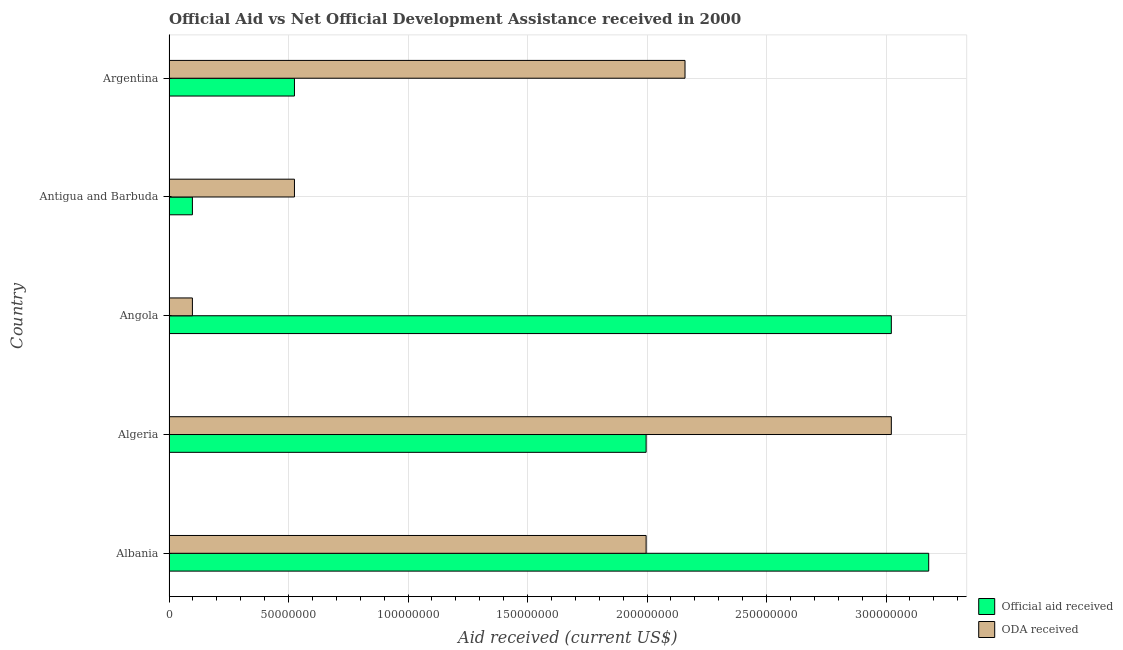Are the number of bars per tick equal to the number of legend labels?
Provide a succinct answer. Yes. Are the number of bars on each tick of the Y-axis equal?
Provide a succinct answer. Yes. How many bars are there on the 3rd tick from the top?
Provide a succinct answer. 2. What is the label of the 3rd group of bars from the top?
Your response must be concise. Angola. In how many cases, is the number of bars for a given country not equal to the number of legend labels?
Offer a very short reply. 0. What is the official aid received in Argentina?
Offer a very short reply. 5.25e+07. Across all countries, what is the maximum oda received?
Ensure brevity in your answer.  3.02e+08. Across all countries, what is the minimum official aid received?
Provide a short and direct response. 9.79e+06. In which country was the official aid received maximum?
Provide a short and direct response. Albania. In which country was the official aid received minimum?
Your answer should be compact. Antigua and Barbuda. What is the total oda received in the graph?
Provide a succinct answer. 7.80e+08. What is the difference between the official aid received in Albania and that in Algeria?
Your answer should be very brief. 1.18e+08. What is the difference between the official aid received in Angola and the oda received in Algeria?
Give a very brief answer. 0. What is the average oda received per country?
Keep it short and to the point. 1.56e+08. What is the difference between the official aid received and oda received in Angola?
Ensure brevity in your answer.  2.92e+08. In how many countries, is the official aid received greater than 40000000 US$?
Your response must be concise. 4. What is the ratio of the official aid received in Albania to that in Argentina?
Provide a short and direct response. 6.05. Is the official aid received in Angola less than that in Antigua and Barbuda?
Give a very brief answer. No. Is the difference between the oda received in Albania and Algeria greater than the difference between the official aid received in Albania and Algeria?
Provide a succinct answer. No. What is the difference between the highest and the second highest official aid received?
Provide a succinct answer. 1.56e+07. What is the difference between the highest and the lowest oda received?
Your answer should be very brief. 2.92e+08. In how many countries, is the oda received greater than the average oda received taken over all countries?
Keep it short and to the point. 3. What does the 2nd bar from the top in Angola represents?
Keep it short and to the point. Official aid received. What does the 2nd bar from the bottom in Antigua and Barbuda represents?
Offer a very short reply. ODA received. How many countries are there in the graph?
Provide a succinct answer. 5. What is the difference between two consecutive major ticks on the X-axis?
Your answer should be compact. 5.00e+07. Where does the legend appear in the graph?
Give a very brief answer. Bottom right. How many legend labels are there?
Give a very brief answer. 2. How are the legend labels stacked?
Provide a succinct answer. Vertical. What is the title of the graph?
Ensure brevity in your answer.  Official Aid vs Net Official Development Assistance received in 2000 . What is the label or title of the X-axis?
Ensure brevity in your answer.  Aid received (current US$). What is the Aid received (current US$) in Official aid received in Albania?
Your answer should be very brief. 3.18e+08. What is the Aid received (current US$) in ODA received in Albania?
Make the answer very short. 2.00e+08. What is the Aid received (current US$) of Official aid received in Algeria?
Keep it short and to the point. 2.00e+08. What is the Aid received (current US$) in ODA received in Algeria?
Ensure brevity in your answer.  3.02e+08. What is the Aid received (current US$) in Official aid received in Angola?
Provide a short and direct response. 3.02e+08. What is the Aid received (current US$) of ODA received in Angola?
Your answer should be compact. 9.79e+06. What is the Aid received (current US$) in Official aid received in Antigua and Barbuda?
Provide a short and direct response. 9.79e+06. What is the Aid received (current US$) of ODA received in Antigua and Barbuda?
Offer a terse response. 5.25e+07. What is the Aid received (current US$) of Official aid received in Argentina?
Give a very brief answer. 5.25e+07. What is the Aid received (current US$) in ODA received in Argentina?
Provide a succinct answer. 2.16e+08. Across all countries, what is the maximum Aid received (current US$) of Official aid received?
Make the answer very short. 3.18e+08. Across all countries, what is the maximum Aid received (current US$) of ODA received?
Provide a succinct answer. 3.02e+08. Across all countries, what is the minimum Aid received (current US$) in Official aid received?
Your answer should be compact. 9.79e+06. Across all countries, what is the minimum Aid received (current US$) of ODA received?
Offer a very short reply. 9.79e+06. What is the total Aid received (current US$) of Official aid received in the graph?
Provide a succinct answer. 8.82e+08. What is the total Aid received (current US$) of ODA received in the graph?
Make the answer very short. 7.80e+08. What is the difference between the Aid received (current US$) of Official aid received in Albania and that in Algeria?
Your answer should be very brief. 1.18e+08. What is the difference between the Aid received (current US$) in ODA received in Albania and that in Algeria?
Offer a very short reply. -1.03e+08. What is the difference between the Aid received (current US$) of Official aid received in Albania and that in Angola?
Offer a terse response. 1.56e+07. What is the difference between the Aid received (current US$) in ODA received in Albania and that in Angola?
Provide a succinct answer. 1.90e+08. What is the difference between the Aid received (current US$) of Official aid received in Albania and that in Antigua and Barbuda?
Offer a very short reply. 3.08e+08. What is the difference between the Aid received (current US$) of ODA received in Albania and that in Antigua and Barbuda?
Your response must be concise. 1.47e+08. What is the difference between the Aid received (current US$) in Official aid received in Albania and that in Argentina?
Your answer should be very brief. 2.65e+08. What is the difference between the Aid received (current US$) of ODA received in Albania and that in Argentina?
Ensure brevity in your answer.  -1.63e+07. What is the difference between the Aid received (current US$) of Official aid received in Algeria and that in Angola?
Offer a very short reply. -1.03e+08. What is the difference between the Aid received (current US$) of ODA received in Algeria and that in Angola?
Give a very brief answer. 2.92e+08. What is the difference between the Aid received (current US$) in Official aid received in Algeria and that in Antigua and Barbuda?
Provide a short and direct response. 1.90e+08. What is the difference between the Aid received (current US$) in ODA received in Algeria and that in Antigua and Barbuda?
Keep it short and to the point. 2.50e+08. What is the difference between the Aid received (current US$) in Official aid received in Algeria and that in Argentina?
Give a very brief answer. 1.47e+08. What is the difference between the Aid received (current US$) in ODA received in Algeria and that in Argentina?
Your answer should be compact. 8.63e+07. What is the difference between the Aid received (current US$) of Official aid received in Angola and that in Antigua and Barbuda?
Your response must be concise. 2.92e+08. What is the difference between the Aid received (current US$) in ODA received in Angola and that in Antigua and Barbuda?
Ensure brevity in your answer.  -4.27e+07. What is the difference between the Aid received (current US$) in Official aid received in Angola and that in Argentina?
Keep it short and to the point. 2.50e+08. What is the difference between the Aid received (current US$) in ODA received in Angola and that in Argentina?
Your answer should be very brief. -2.06e+08. What is the difference between the Aid received (current US$) of Official aid received in Antigua and Barbuda and that in Argentina?
Provide a succinct answer. -4.27e+07. What is the difference between the Aid received (current US$) in ODA received in Antigua and Barbuda and that in Argentina?
Provide a short and direct response. -1.63e+08. What is the difference between the Aid received (current US$) in Official aid received in Albania and the Aid received (current US$) in ODA received in Algeria?
Your answer should be very brief. 1.56e+07. What is the difference between the Aid received (current US$) of Official aid received in Albania and the Aid received (current US$) of ODA received in Angola?
Your response must be concise. 3.08e+08. What is the difference between the Aid received (current US$) of Official aid received in Albania and the Aid received (current US$) of ODA received in Antigua and Barbuda?
Make the answer very short. 2.65e+08. What is the difference between the Aid received (current US$) of Official aid received in Albania and the Aid received (current US$) of ODA received in Argentina?
Your response must be concise. 1.02e+08. What is the difference between the Aid received (current US$) of Official aid received in Algeria and the Aid received (current US$) of ODA received in Angola?
Your answer should be very brief. 1.90e+08. What is the difference between the Aid received (current US$) in Official aid received in Algeria and the Aid received (current US$) in ODA received in Antigua and Barbuda?
Provide a succinct answer. 1.47e+08. What is the difference between the Aid received (current US$) in Official aid received in Algeria and the Aid received (current US$) in ODA received in Argentina?
Your answer should be very brief. -1.63e+07. What is the difference between the Aid received (current US$) of Official aid received in Angola and the Aid received (current US$) of ODA received in Antigua and Barbuda?
Provide a succinct answer. 2.50e+08. What is the difference between the Aid received (current US$) of Official aid received in Angola and the Aid received (current US$) of ODA received in Argentina?
Offer a very short reply. 8.63e+07. What is the difference between the Aid received (current US$) of Official aid received in Antigua and Barbuda and the Aid received (current US$) of ODA received in Argentina?
Give a very brief answer. -2.06e+08. What is the average Aid received (current US$) in Official aid received per country?
Your response must be concise. 1.76e+08. What is the average Aid received (current US$) of ODA received per country?
Ensure brevity in your answer.  1.56e+08. What is the difference between the Aid received (current US$) of Official aid received and Aid received (current US$) of ODA received in Albania?
Provide a succinct answer. 1.18e+08. What is the difference between the Aid received (current US$) of Official aid received and Aid received (current US$) of ODA received in Algeria?
Your response must be concise. -1.03e+08. What is the difference between the Aid received (current US$) in Official aid received and Aid received (current US$) in ODA received in Angola?
Your response must be concise. 2.92e+08. What is the difference between the Aid received (current US$) in Official aid received and Aid received (current US$) in ODA received in Antigua and Barbuda?
Offer a very short reply. -4.27e+07. What is the difference between the Aid received (current US$) of Official aid received and Aid received (current US$) of ODA received in Argentina?
Provide a short and direct response. -1.63e+08. What is the ratio of the Aid received (current US$) in Official aid received in Albania to that in Algeria?
Provide a succinct answer. 1.59. What is the ratio of the Aid received (current US$) in ODA received in Albania to that in Algeria?
Make the answer very short. 0.66. What is the ratio of the Aid received (current US$) of Official aid received in Albania to that in Angola?
Your answer should be very brief. 1.05. What is the ratio of the Aid received (current US$) of ODA received in Albania to that in Angola?
Ensure brevity in your answer.  20.39. What is the ratio of the Aid received (current US$) of Official aid received in Albania to that in Antigua and Barbuda?
Your response must be concise. 32.47. What is the ratio of the Aid received (current US$) of ODA received in Albania to that in Antigua and Barbuda?
Offer a terse response. 3.8. What is the ratio of the Aid received (current US$) in Official aid received in Albania to that in Argentina?
Make the answer very short. 6.06. What is the ratio of the Aid received (current US$) in ODA received in Albania to that in Argentina?
Your answer should be very brief. 0.92. What is the ratio of the Aid received (current US$) of Official aid received in Algeria to that in Angola?
Keep it short and to the point. 0.66. What is the ratio of the Aid received (current US$) in ODA received in Algeria to that in Angola?
Provide a succinct answer. 30.87. What is the ratio of the Aid received (current US$) in Official aid received in Algeria to that in Antigua and Barbuda?
Your answer should be compact. 20.39. What is the ratio of the Aid received (current US$) of ODA received in Algeria to that in Antigua and Barbuda?
Your response must be concise. 5.76. What is the ratio of the Aid received (current US$) of Official aid received in Algeria to that in Argentina?
Provide a succinct answer. 3.8. What is the ratio of the Aid received (current US$) in ODA received in Algeria to that in Argentina?
Your response must be concise. 1.4. What is the ratio of the Aid received (current US$) of Official aid received in Angola to that in Antigua and Barbuda?
Give a very brief answer. 30.87. What is the ratio of the Aid received (current US$) of ODA received in Angola to that in Antigua and Barbuda?
Your answer should be compact. 0.19. What is the ratio of the Aid received (current US$) in Official aid received in Angola to that in Argentina?
Keep it short and to the point. 5.76. What is the ratio of the Aid received (current US$) of ODA received in Angola to that in Argentina?
Offer a terse response. 0.05. What is the ratio of the Aid received (current US$) in Official aid received in Antigua and Barbuda to that in Argentina?
Offer a terse response. 0.19. What is the ratio of the Aid received (current US$) in ODA received in Antigua and Barbuda to that in Argentina?
Offer a terse response. 0.24. What is the difference between the highest and the second highest Aid received (current US$) in Official aid received?
Your response must be concise. 1.56e+07. What is the difference between the highest and the second highest Aid received (current US$) of ODA received?
Your response must be concise. 8.63e+07. What is the difference between the highest and the lowest Aid received (current US$) in Official aid received?
Keep it short and to the point. 3.08e+08. What is the difference between the highest and the lowest Aid received (current US$) in ODA received?
Offer a very short reply. 2.92e+08. 